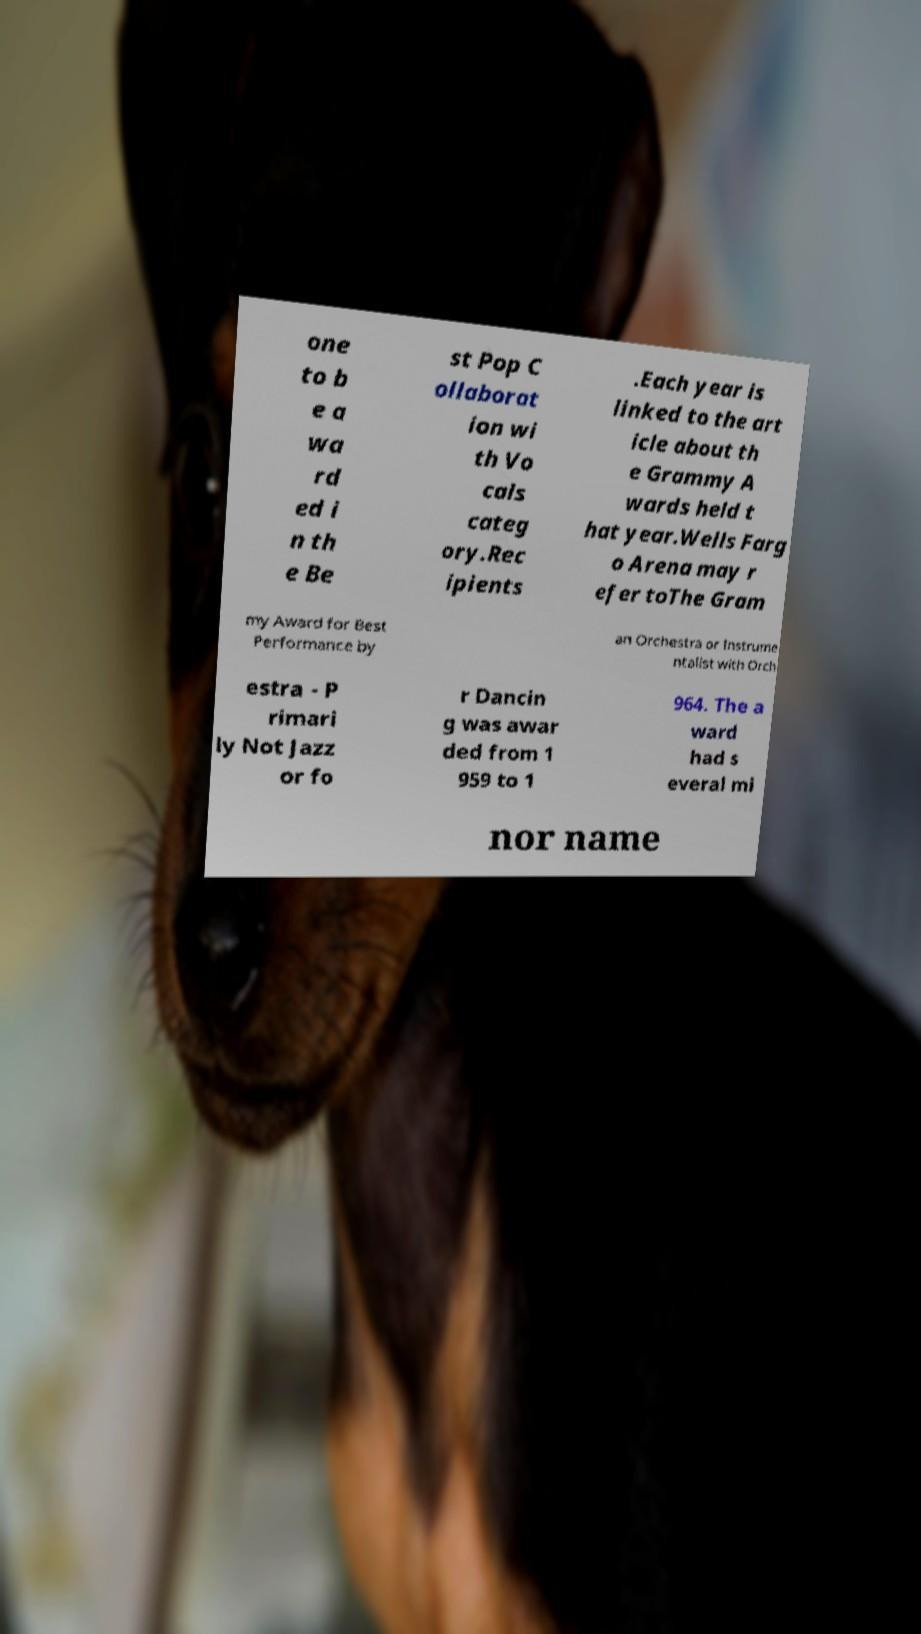What messages or text are displayed in this image? I need them in a readable, typed format. one to b e a wa rd ed i n th e Be st Pop C ollaborat ion wi th Vo cals categ ory.Rec ipients .Each year is linked to the art icle about th e Grammy A wards held t hat year.Wells Farg o Arena may r efer toThe Gram my Award for Best Performance by an Orchestra or Instrume ntalist with Orch estra - P rimari ly Not Jazz or fo r Dancin g was awar ded from 1 959 to 1 964. The a ward had s everal mi nor name 